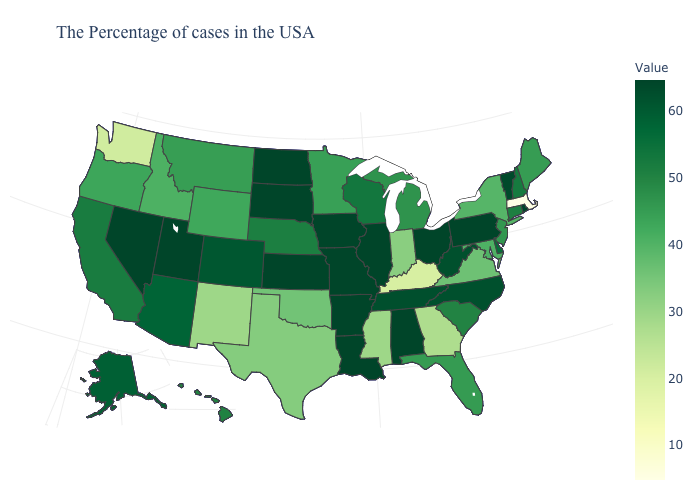Which states hav the highest value in the Northeast?
Give a very brief answer. Rhode Island, Pennsylvania. Among the states that border Indiana , which have the highest value?
Keep it brief. Ohio, Illinois. Among the states that border North Carolina , does Georgia have the lowest value?
Answer briefly. Yes. Does New York have the highest value in the Northeast?
Quick response, please. No. 